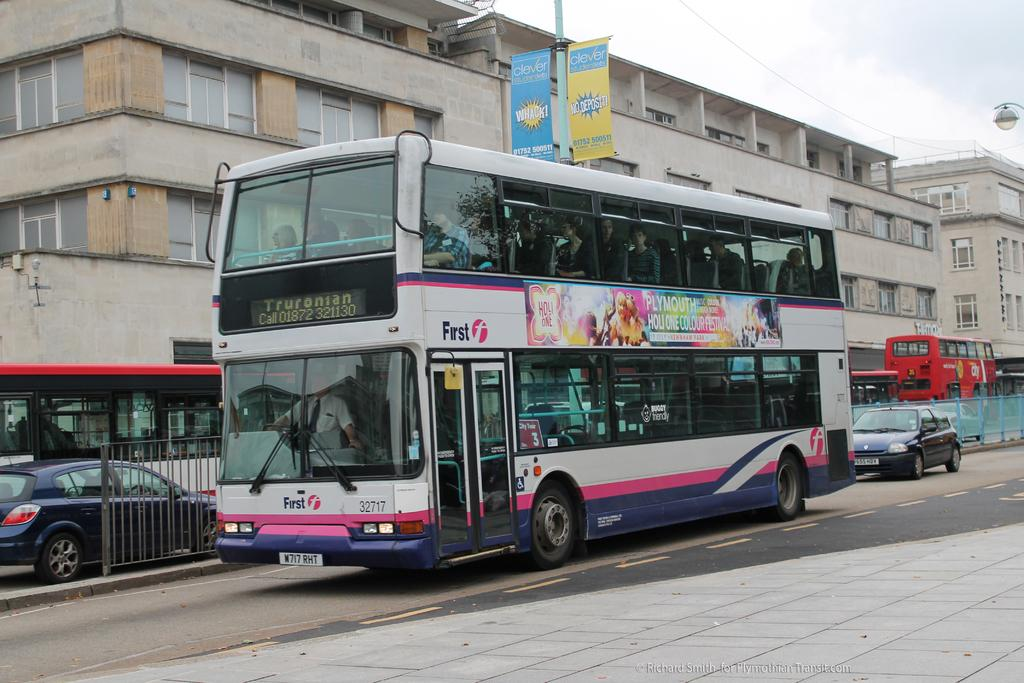<image>
Create a compact narrative representing the image presented. a colorful double decker bus with the word First on the front 